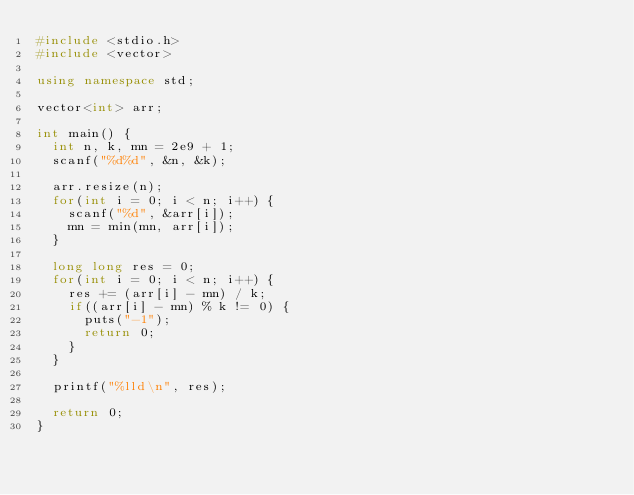Convert code to text. <code><loc_0><loc_0><loc_500><loc_500><_C++_>#include <stdio.h>
#include <vector>

using namespace std;

vector<int> arr;

int main() {
	int n, k, mn = 2e9 + 1;
	scanf("%d%d", &n, &k);

	arr.resize(n);
	for(int i = 0; i < n; i++) {
		scanf("%d", &arr[i]);
		mn = min(mn, arr[i]);
	}

	long long res = 0;
	for(int i = 0; i < n; i++) {
		res += (arr[i] - mn) / k;
		if((arr[i] - mn) % k != 0) {
			puts("-1");
			return 0;
		}
	}

	printf("%lld\n", res);

  return 0;
}

</code> 